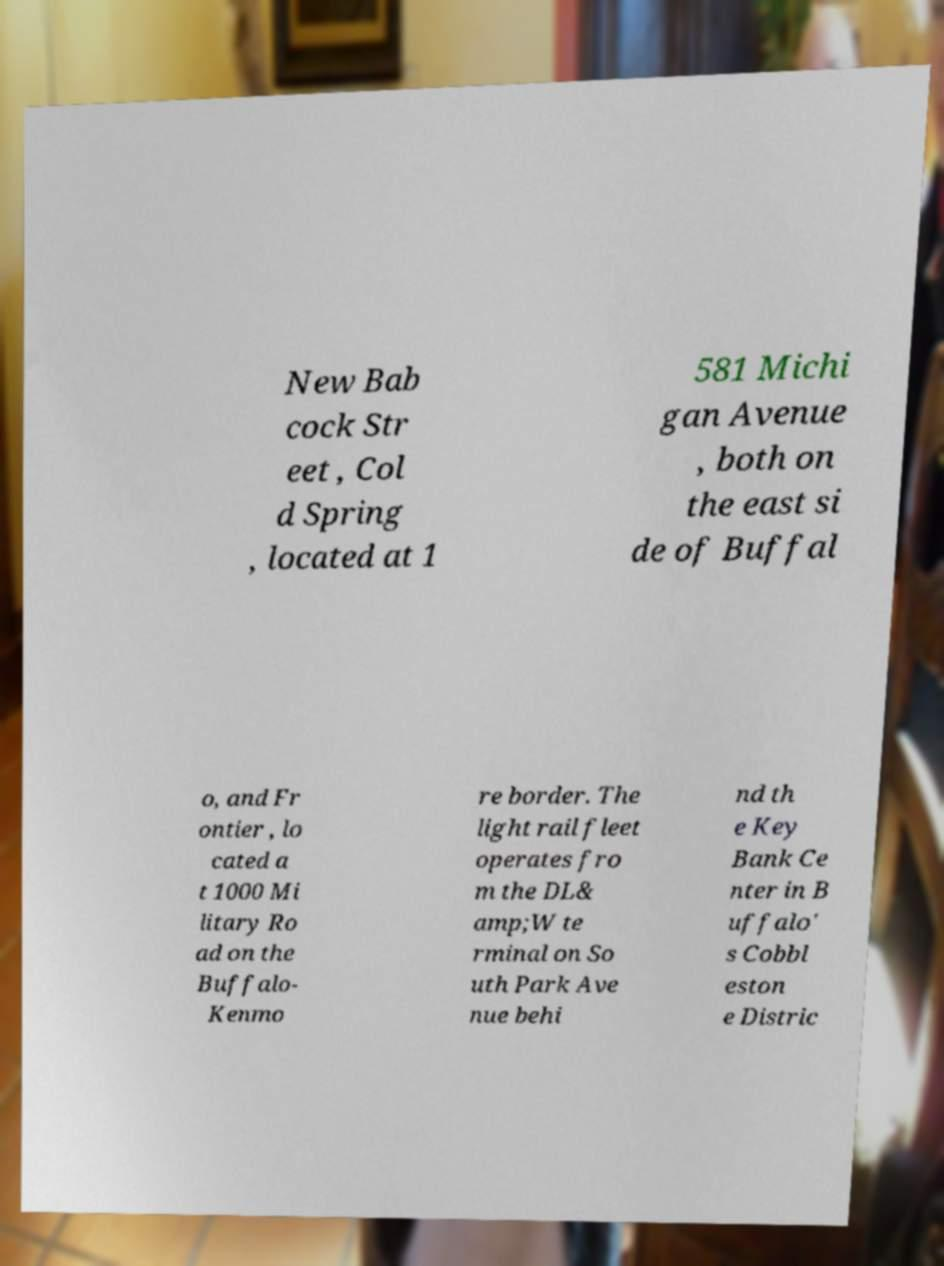Please read and relay the text visible in this image. What does it say? New Bab cock Str eet , Col d Spring , located at 1 581 Michi gan Avenue , both on the east si de of Buffal o, and Fr ontier , lo cated a t 1000 Mi litary Ro ad on the Buffalo- Kenmo re border. The light rail fleet operates fro m the DL& amp;W te rminal on So uth Park Ave nue behi nd th e Key Bank Ce nter in B uffalo' s Cobbl eston e Distric 